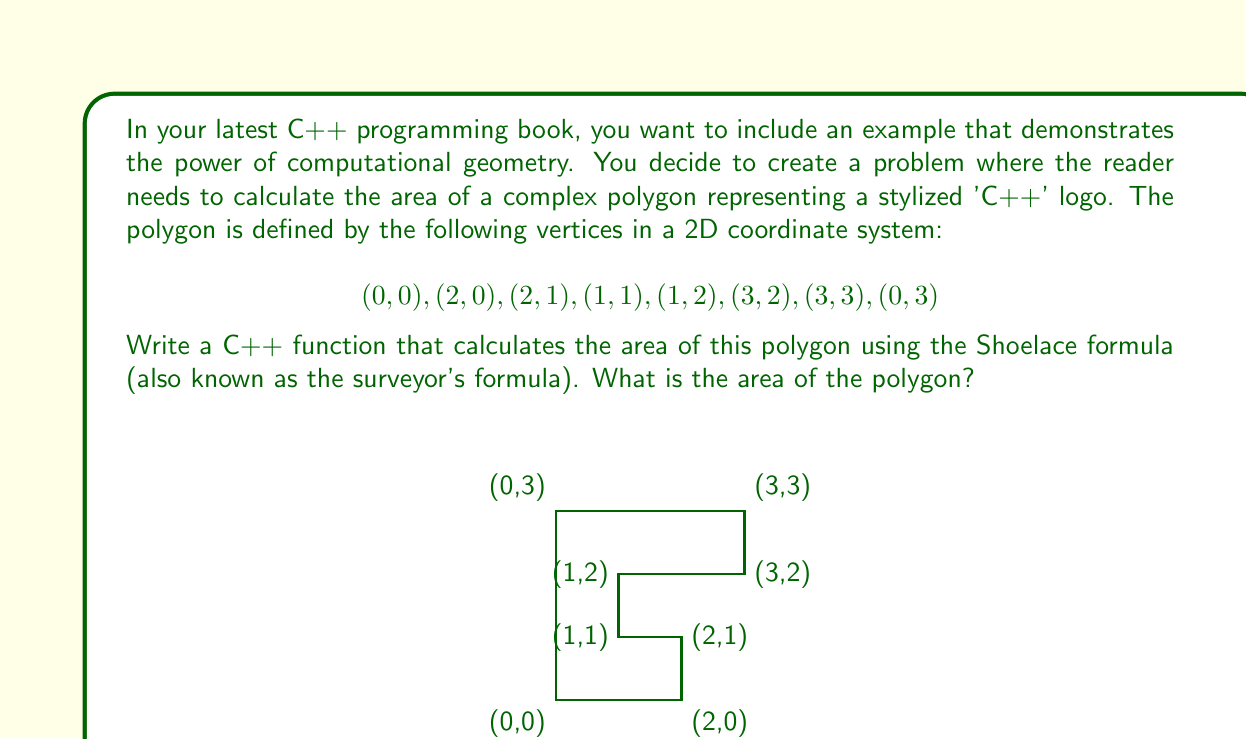Give your solution to this math problem. To solve this problem, we'll use the Shoelace formula, which is an efficient method for calculating the area of a polygon given its vertices. The formula is:

$$A = \frac{1}{2}\left|\sum_{i=1}^{n} (x_i y_{i+1} - x_{i+1} y_i)\right|$$

where $(x_i, y_i)$ are the coordinates of the i-th vertex, and $(x_{n+1}, y_{n+1}) = (x_1, y_1)$.

Let's apply this formula step by step:

1) First, let's list out our vertices in order:
   $(x_1, y_1) = (0, 0)$
   $(x_2, y_2) = (2, 0)$
   $(x_3, y_3) = (2, 1)$
   $(x_4, y_4) = (1, 1)$
   $(x_5, y_5) = (1, 2)$
   $(x_6, y_6) = (3, 2)$
   $(x_7, y_7) = (3, 3)$
   $(x_8, y_8) = (0, 3)$

2) Now, let's calculate each term of the sum:
   $(0 \cdot 0) - (2 \cdot 0) = 0$
   $(2 \cdot 1) - (2 \cdot 0) = 2$
   $(2 \cdot 1) - (1 \cdot 1) = 1$
   $(1 \cdot 2) - (1 \cdot 1) = 1$
   $(1 \cdot 2) - (3 \cdot 2) = -4$
   $(3 \cdot 3) - (3 \cdot 2) = 3$
   $(3 \cdot 3) - (0 \cdot 3) = 9$
   $(0 \cdot 0) - (0 \cdot 3) = 0$

3) Sum up all these terms:
   $0 + 2 + 1 + 1 + (-4) + 3 + 9 + 0 = 12$

4) Take the absolute value and divide by 2:
   $\frac{1}{2}|12| = 6$

Therefore, the area of the polygon is 6 square units.

In C++, this could be implemented as follows:

```cpp
double calculatePolygonArea(const vector<pair<double, double>>& vertices) {
    double area = 0.0;
    int n = vertices.size();
    for (int i = 0; i < n; i++) {
        int j = (i + 1) % n;
        area += vertices[i].first * vertices[j].second;
        area -= vertices[j].first * vertices[i].second;
    }
    return abs(area) / 2.0;
}
```

This function takes a vector of vertex coordinates and returns the area of the polygon.
Answer: 6 square units 